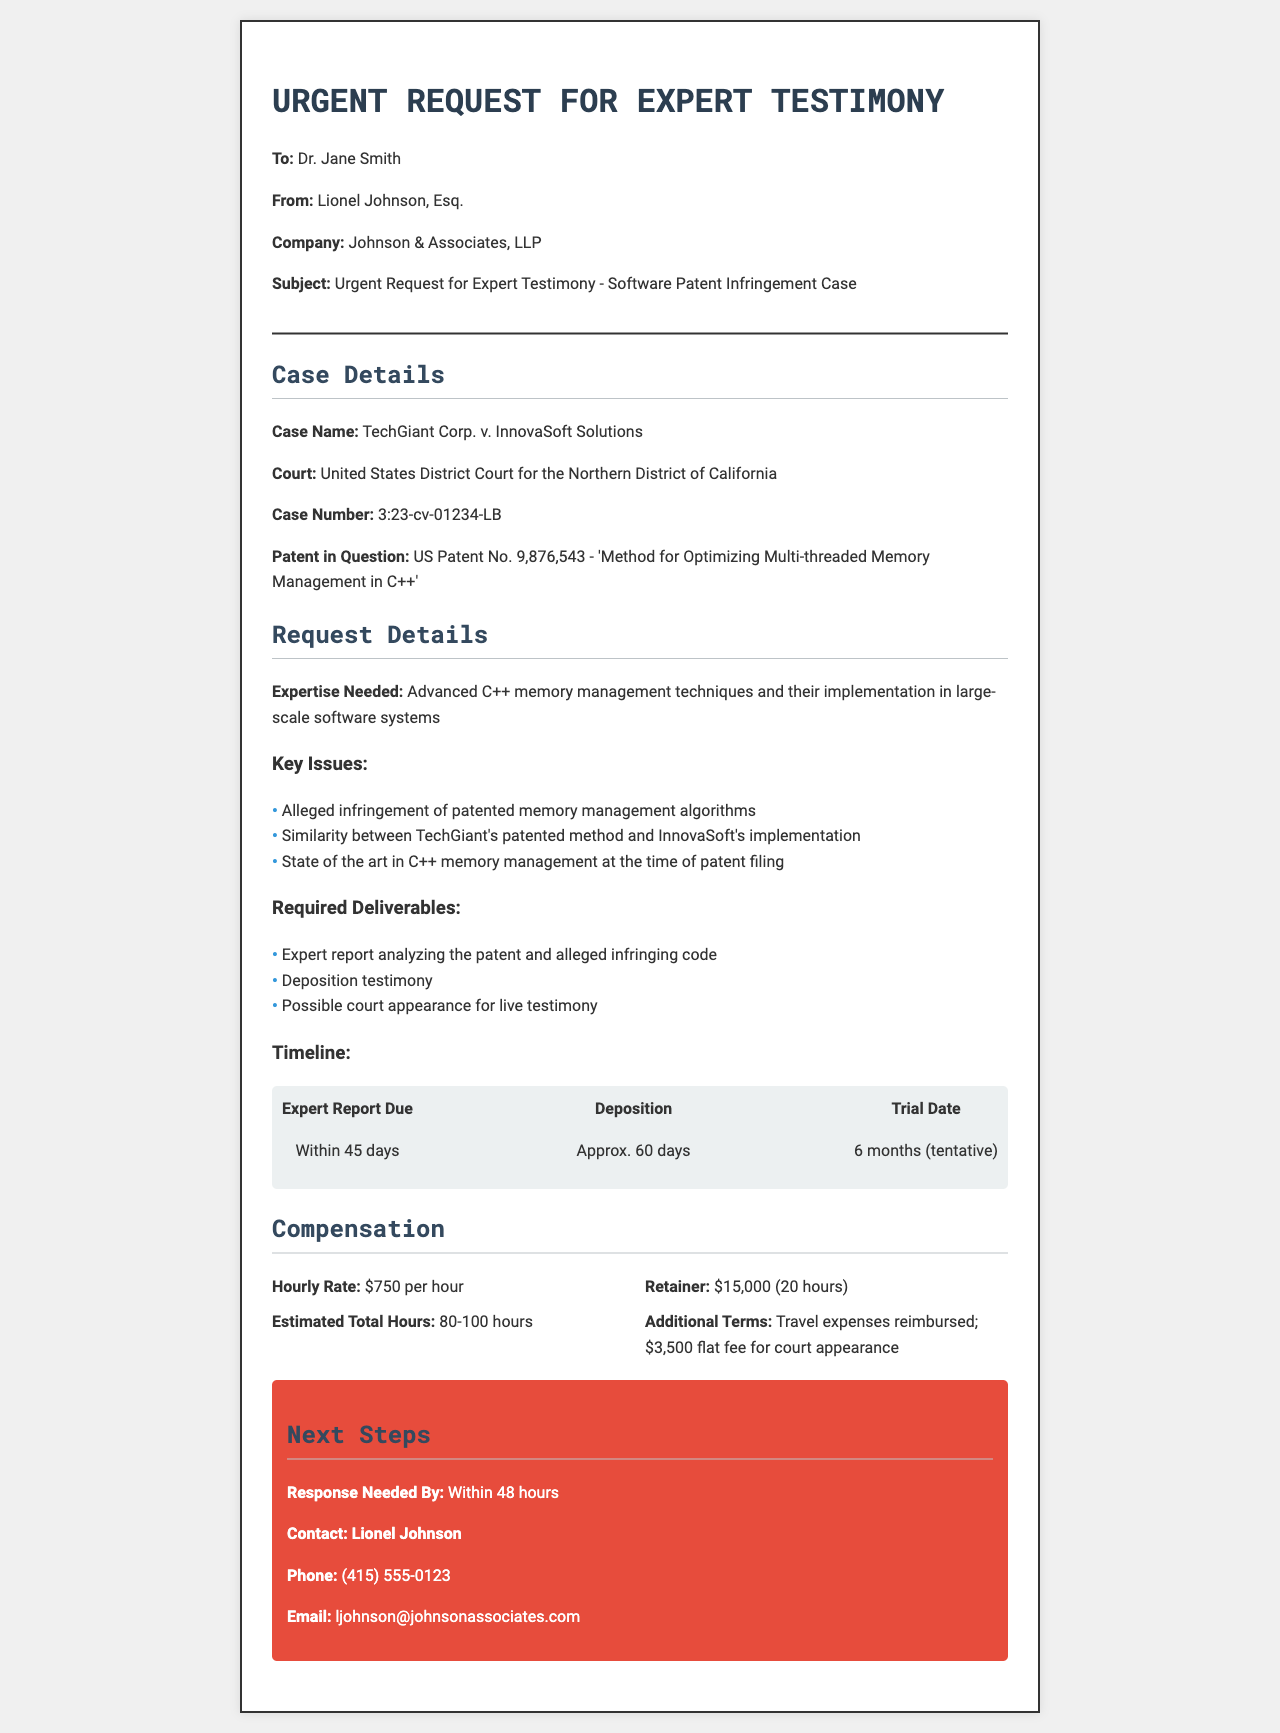What is the case name? The case name is explicitly provided under the "Case Details" section of the document.
Answer: TechGiant Corp. v. InnovaSoft Solutions What is the court for this case? The court is specified along with the details of the case in the document.
Answer: United States District Court for the Northern District of California Who is the contact person for this request? The document lists a contact person for further communication regarding the request.
Answer: Lionel Johnson What is the hourly rate for the expert? The compensation section details the rate offered for the expert's services.
Answer: $750 per hour How soon is a response needed? The urgency of the request is mentioned in the "Next Steps" section of the document.
Answer: Within 48 hours List one required deliverable for the expert. The document outlines several deliverables required from the expert.
Answer: Expert report analyzing the patent and alleged infringing code What is the retainer fee? The document specifies the retainer fee for the expert's engagement.
Answer: $15,000 What is the estimated total number of hours expected from the expert? This information is provided in the compensation section, detailing the expected involvement of the expert.
Answer: 80-100 hours When is the trial date tentatively scheduled? The "Timeline" section includes information regarding the estimated time frame for the trial.
Answer: 6 months (tentative) 